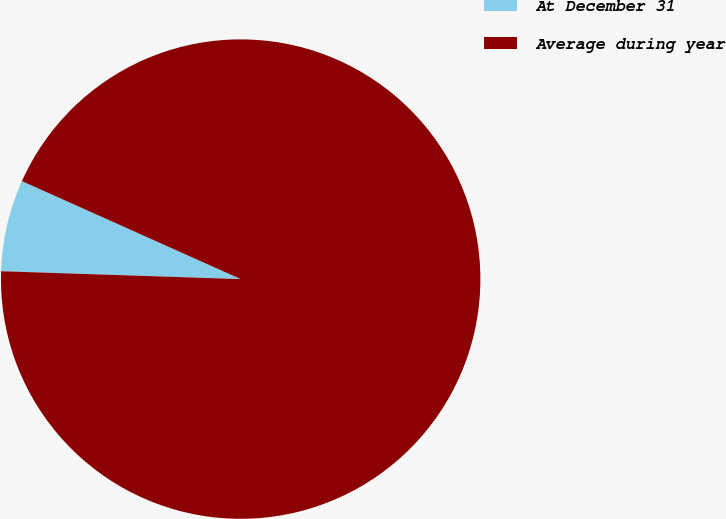<chart> <loc_0><loc_0><loc_500><loc_500><pie_chart><fcel>At December 31<fcel>Average during year<nl><fcel>6.18%<fcel>93.82%<nl></chart> 